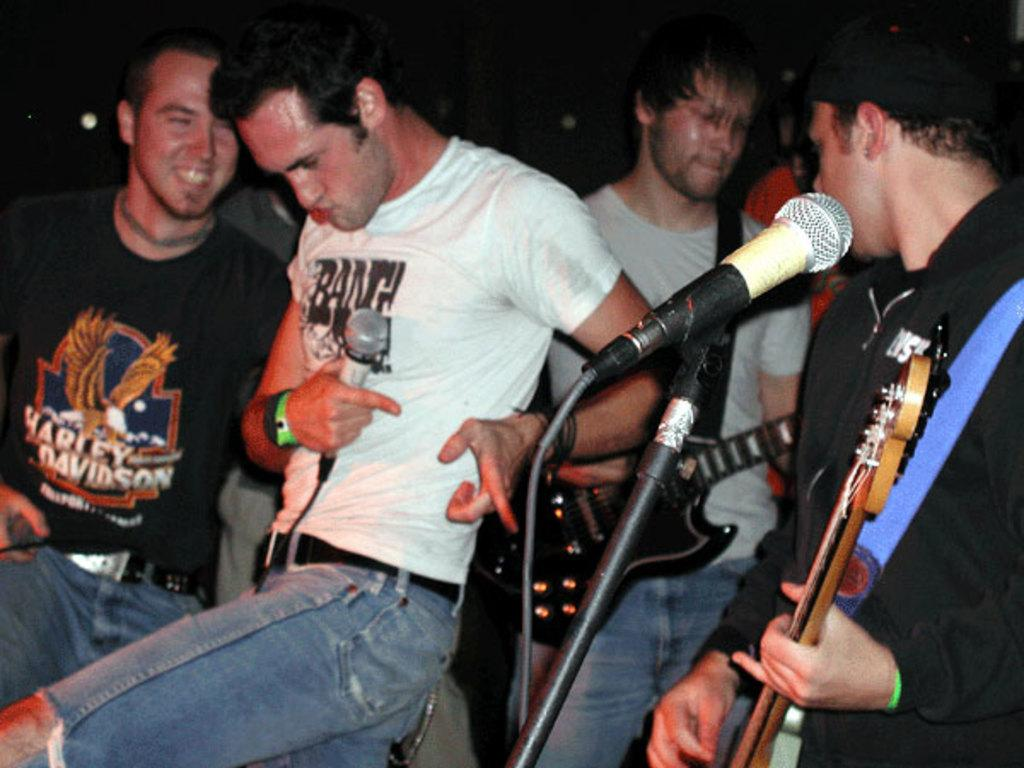What is the person in the image doing? There is a person playing a guitar in the image. What object is the man holding in the image? The man is holding a microphone in the image. What position are the people in the image in? The people in the image are standing. How many cabbages are visible in the image? There are no cabbages present in the image. What day of the week is it in the image? The day of the week is not visible or mentioned in the image. 